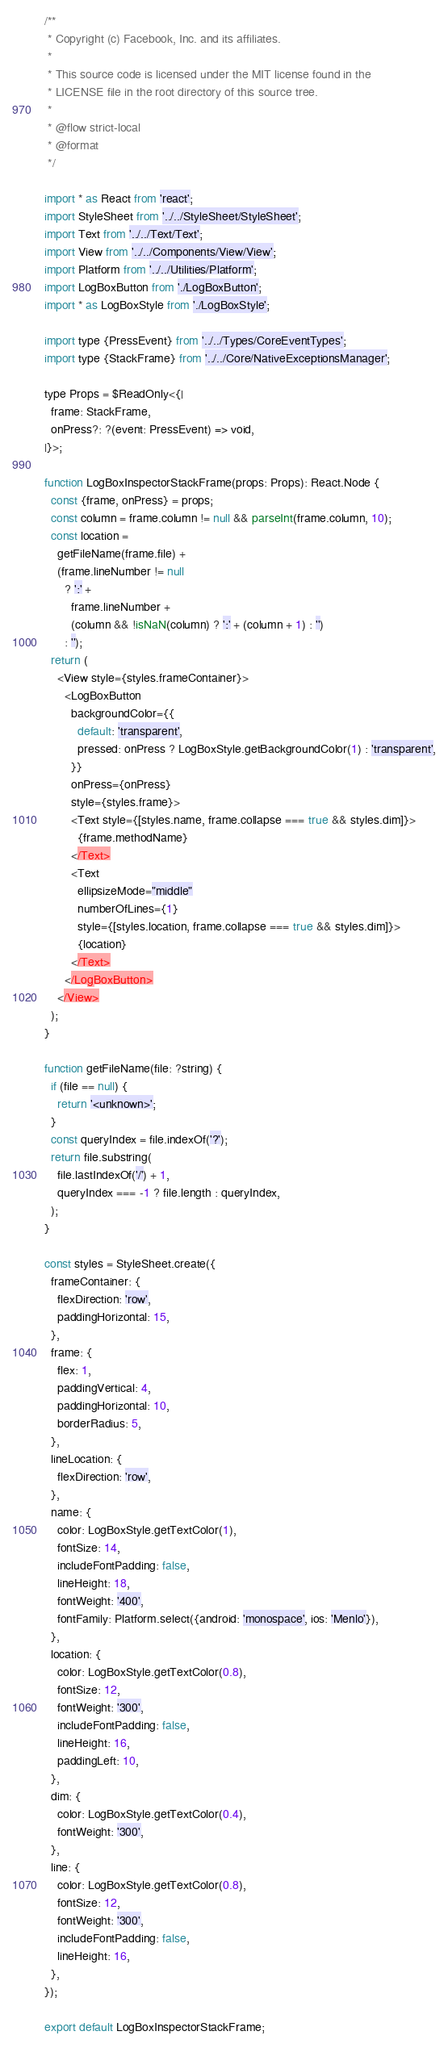Convert code to text. <code><loc_0><loc_0><loc_500><loc_500><_JavaScript_>/**
 * Copyright (c) Facebook, Inc. and its affiliates.
 *
 * This source code is licensed under the MIT license found in the
 * LICENSE file in the root directory of this source tree.
 *
 * @flow strict-local
 * @format
 */

import * as React from 'react';
import StyleSheet from '../../StyleSheet/StyleSheet';
import Text from '../../Text/Text';
import View from '../../Components/View/View';
import Platform from '../../Utilities/Platform';
import LogBoxButton from './LogBoxButton';
import * as LogBoxStyle from './LogBoxStyle';

import type {PressEvent} from '../../Types/CoreEventTypes';
import type {StackFrame} from '../../Core/NativeExceptionsManager';

type Props = $ReadOnly<{|
  frame: StackFrame,
  onPress?: ?(event: PressEvent) => void,
|}>;

function LogBoxInspectorStackFrame(props: Props): React.Node {
  const {frame, onPress} = props;
  const column = frame.column != null && parseInt(frame.column, 10);
  const location =
    getFileName(frame.file) +
    (frame.lineNumber != null
      ? ':' +
        frame.lineNumber +
        (column && !isNaN(column) ? ':' + (column + 1) : '')
      : '');
  return (
    <View style={styles.frameContainer}>
      <LogBoxButton
        backgroundColor={{
          default: 'transparent',
          pressed: onPress ? LogBoxStyle.getBackgroundColor(1) : 'transparent',
        }}
        onPress={onPress}
        style={styles.frame}>
        <Text style={[styles.name, frame.collapse === true && styles.dim]}>
          {frame.methodName}
        </Text>
        <Text
          ellipsizeMode="middle"
          numberOfLines={1}
          style={[styles.location, frame.collapse === true && styles.dim]}>
          {location}
        </Text>
      </LogBoxButton>
    </View>
  );
}

function getFileName(file: ?string) {
  if (file == null) {
    return '<unknown>';
  }
  const queryIndex = file.indexOf('?');
  return file.substring(
    file.lastIndexOf('/') + 1,
    queryIndex === -1 ? file.length : queryIndex,
  );
}

const styles = StyleSheet.create({
  frameContainer: {
    flexDirection: 'row',
    paddingHorizontal: 15,
  },
  frame: {
    flex: 1,
    paddingVertical: 4,
    paddingHorizontal: 10,
    borderRadius: 5,
  },
  lineLocation: {
    flexDirection: 'row',
  },
  name: {
    color: LogBoxStyle.getTextColor(1),
    fontSize: 14,
    includeFontPadding: false,
    lineHeight: 18,
    fontWeight: '400',
    fontFamily: Platform.select({android: 'monospace', ios: 'Menlo'}),
  },
  location: {
    color: LogBoxStyle.getTextColor(0.8),
    fontSize: 12,
    fontWeight: '300',
    includeFontPadding: false,
    lineHeight: 16,
    paddingLeft: 10,
  },
  dim: {
    color: LogBoxStyle.getTextColor(0.4),
    fontWeight: '300',
  },
  line: {
    color: LogBoxStyle.getTextColor(0.8),
    fontSize: 12,
    fontWeight: '300',
    includeFontPadding: false,
    lineHeight: 16,
  },
});

export default LogBoxInspectorStackFrame;
</code> 